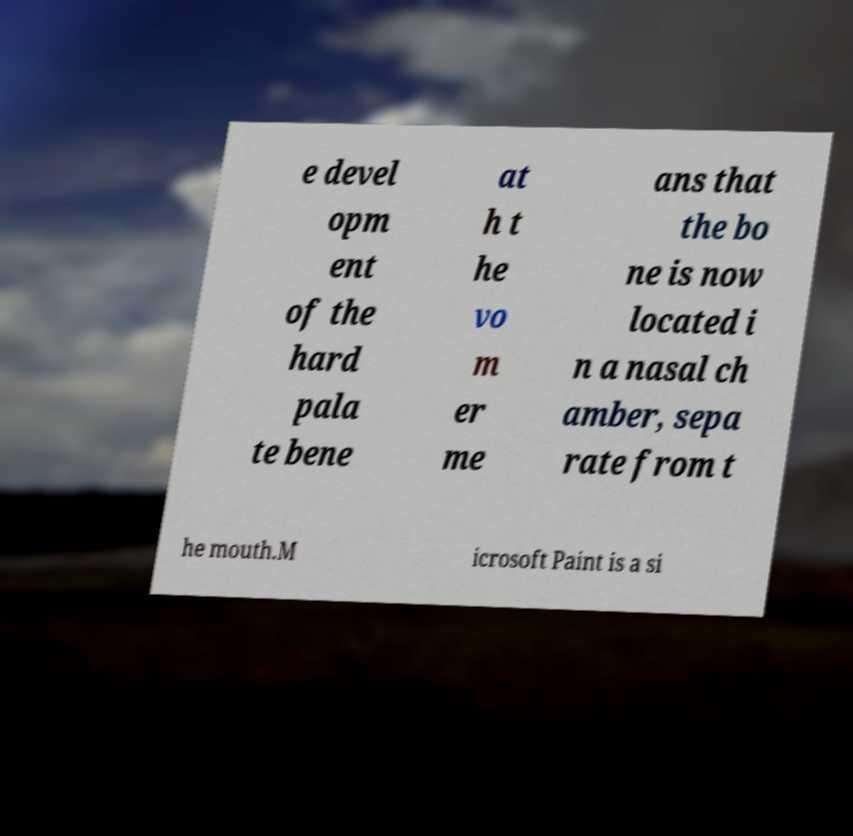Could you extract and type out the text from this image? e devel opm ent of the hard pala te bene at h t he vo m er me ans that the bo ne is now located i n a nasal ch amber, sepa rate from t he mouth.M icrosoft Paint is a si 